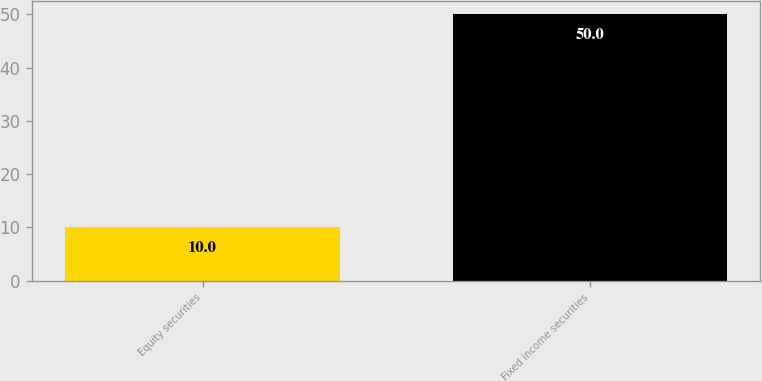Convert chart to OTSL. <chart><loc_0><loc_0><loc_500><loc_500><bar_chart><fcel>Equity securities<fcel>Fixed income securities<nl><fcel>10<fcel>50<nl></chart> 